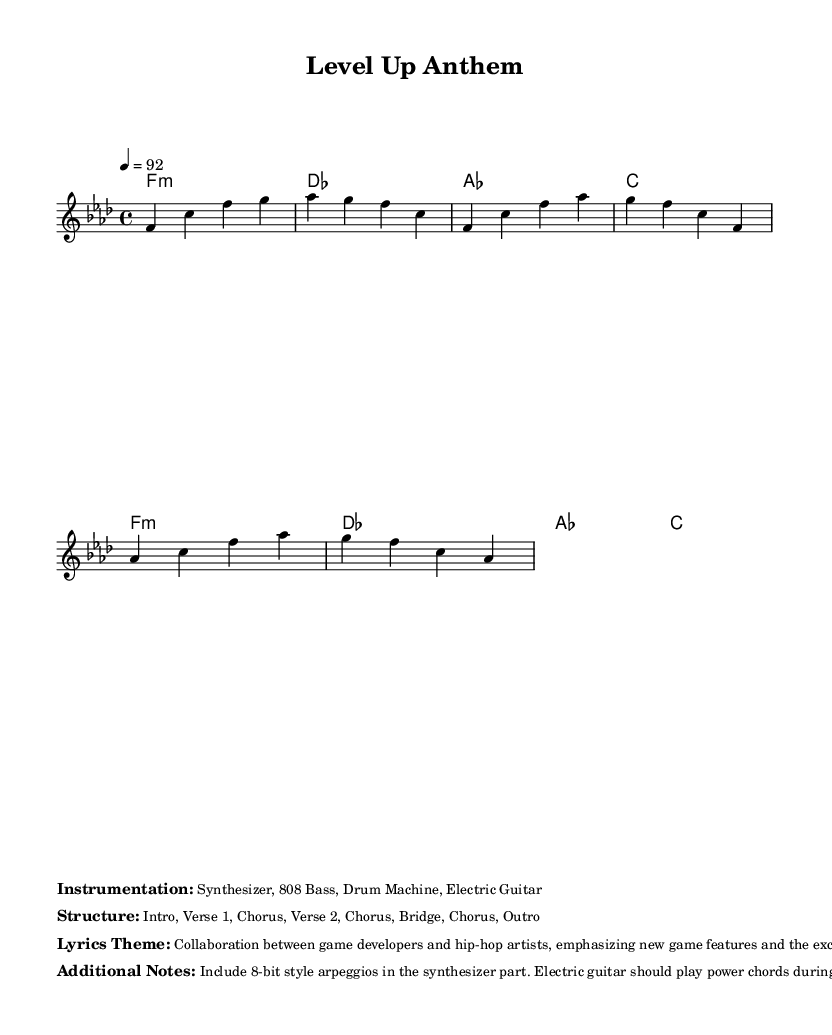What is the key signature of this music? The key signature indicates F minor, which has four flats: B♭, E♭, A♭, and D♭. This is determined by locating the key signature in the sheet music.
Answer: F minor What is the time signature of this piece? The time signature is found at the beginning of the score, indicating that there are four beats per measure. The notation shows a 4 over 4, which is commonly referred to as "four-four" time.
Answer: 4/4 What is the tempo marking for this music? The tempo marking specifies the speed of the piece, indicated by the instruction "4 = 92" at the beginning of the score. This means there should be 92 beats per minute when counting the quarter note as one beat.
Answer: 92 What instruments are featured in this track? The instrumentation is listed in the markup, highlighting the specific musical elements used. The description includes synthesizer, 808 bass, drum machine, and electric guitar.
Answer: Synthesizer, 808 Bass, Drum Machine, Electric Guitar How many choruses are indicated in the structure? The structure section of the markup outlines the different sections of the track. By counting the occurrences of the word "Chorus," it is noted that there are three choruses present throughout the song.
Answer: 3 What is the theme of the lyrics in this piece? The lyrics theme is found in the markup and focuses on collaboration between game developers and hip-hop artists while emphasizing new game features and excitement. This is directly expressed in the lyrics theme section.
Answer: Collaboration between game developers and hip-hop artists What rhythmic style is suggested for the synthesizer part? The additional notes specify the desired style for the synthesizer part, indicating the inclusion of 8-bit style arpeggios. This detail suggests a retro gaming aesthetic which fits well within the hip-hop genre.
Answer: 8-bit style arpeggios 